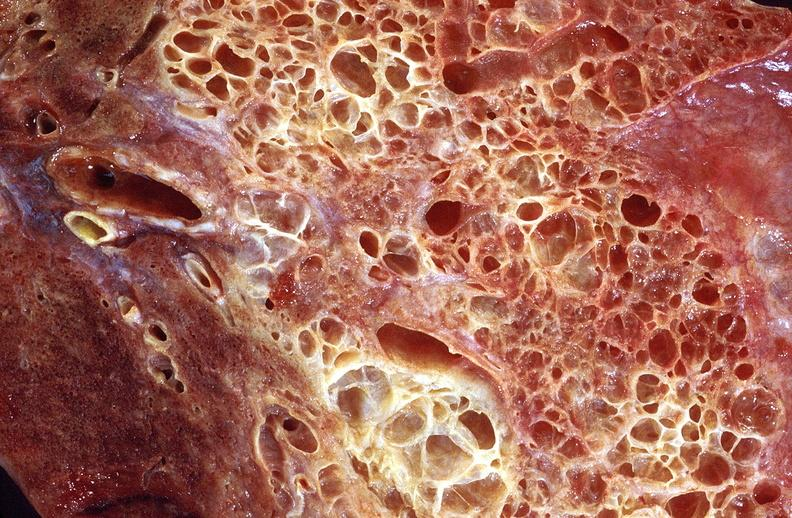s respiratory present?
Answer the question using a single word or phrase. Yes 